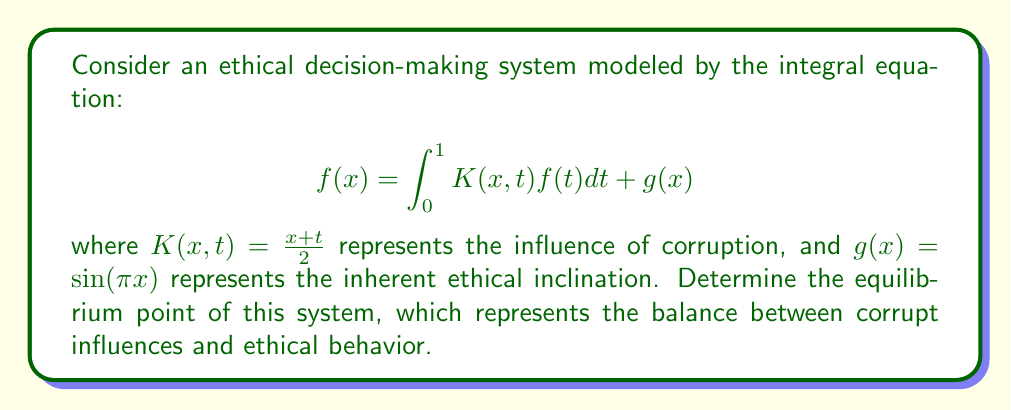Show me your answer to this math problem. To solve this integral equation and find the equilibrium point, we'll follow these steps:

1) First, we assume that $f(x)$ has the form $f(x) = a\sin(\pi x)$, where $a$ is a constant we need to determine.

2) Substitute this into the integral equation:

   $$a\sin(\pi x) = \int_0^1 \frac{x+t}{2} \cdot a\sin(\pi t)dt + \sin(\pi x)$$

3) Simplify the left side of the equation:

   $$a\sin(\pi x) = \frac{ax}{2}\int_0^1 \sin(\pi t)dt + \frac{a}{2}\int_0^1 t\sin(\pi t)dt + \sin(\pi x)$$

4) Solve the integrals:

   $\int_0^1 \sin(\pi t)dt = \frac{2}{\pi}$
   
   $\int_0^1 t\sin(\pi t)dt = \frac{1}{\pi}$

5) Substitute these results:

   $$a\sin(\pi x) = \frac{ax}{\pi} + \frac{a}{2\pi} + \sin(\pi x)$$

6) For this equation to be true for all $x$, the coefficients of $\sin(\pi x)$ must be equal on both sides:

   $$a = \frac{ax}{\pi} + \frac{a}{2\pi} + 1$$

7) This must be true for all $x$, so we can choose $x=\frac{1}{2}$:

   $$a = \frac{a}{2\pi} + \frac{a}{2\pi} + 1$$

8) Solve for $a$:

   $$a = \frac{a}{\pi} + 1$$
   $$a - \frac{a}{\pi} = 1$$
   $$a(\frac{\pi-1}{\pi}) = 1$$
   $$a = \frac{\pi}{\pi-1}$$

9) Therefore, the equilibrium solution is:

   $$f(x) = \frac{\pi}{\pi-1}\sin(\pi x)$$

The equilibrium point, which represents the balance between corrupt influences and ethical behavior, is the maximum of this function, occurring at $x=\frac{1}{2}$.
Answer: $(\frac{1}{2}, \frac{\pi}{\pi-1})$ 